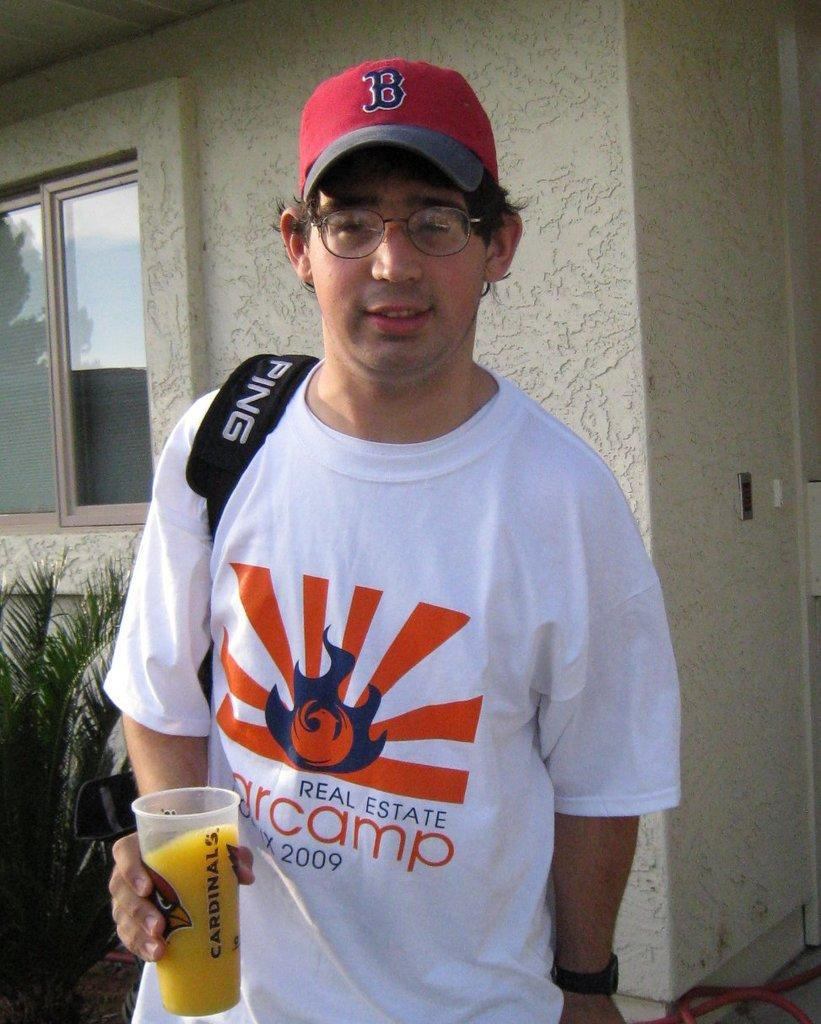<image>
Write a terse but informative summary of the picture. Man wearing a shirt that says real estate on it. 